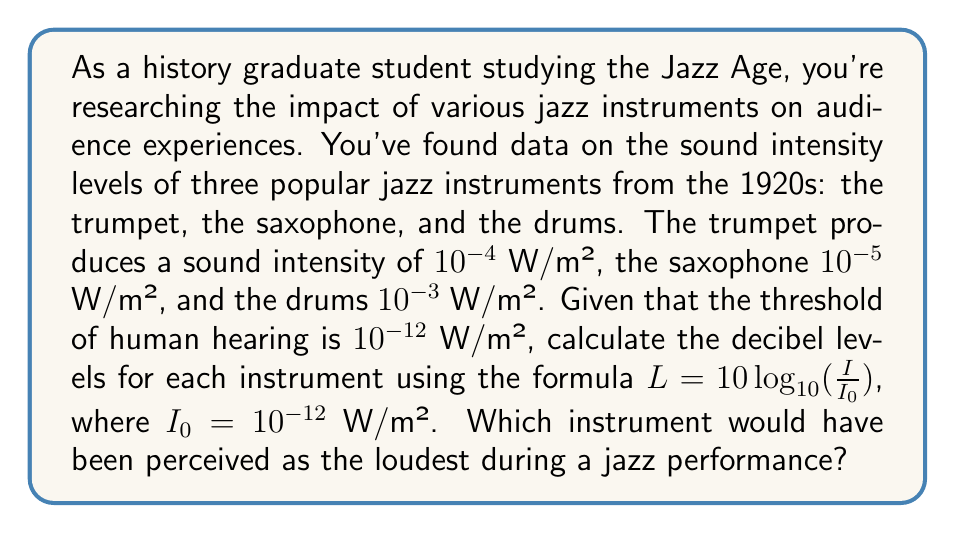Solve this math problem. To solve this problem, we'll use the given formula for sound intensity level in decibels:

$L = 10 \log_{10}(\frac{I}{I_0})$

Where:
$L$ is the sound intensity level in decibels (dB)
$I$ is the sound intensity of the instrument
$I_0$ is the threshold of human hearing ($10^{-12}$ W/m²)

For each instrument:

1. Trumpet ($I = 10^{-4}$ W/m²):
   $L_{trumpet} = 10 \log_{10}(\frac{10^{-4}}{10^{-12}})$
   $= 10 \log_{10}(10^8) = 10 \cdot 8 = 80$ dB

2. Saxophone ($I = 10^{-5}$ W/m²):
   $L_{saxophone} = 10 \log_{10}(\frac{10^{-5}}{10^{-12}})$
   $= 10 \log_{10}(10^7) = 10 \cdot 7 = 70$ dB

3. Drums ($I = 10^{-3}$ W/m²):
   $L_{drums} = 10 \log_{10}(\frac{10^{-3}}{10^{-12}})$
   $= 10 \log_{10}(10^9) = 10 \cdot 9 = 90$ dB

Comparing the decibel levels, we can see that the drums have the highest value at 90 dB, making them the loudest instrument among the three.
Answer: The decibel levels are:
Trumpet: 80 dB
Saxophone: 70 dB
Drums: 90 dB

The drums, at 90 dB, would have been perceived as the loudest instrument during a jazz performance. 